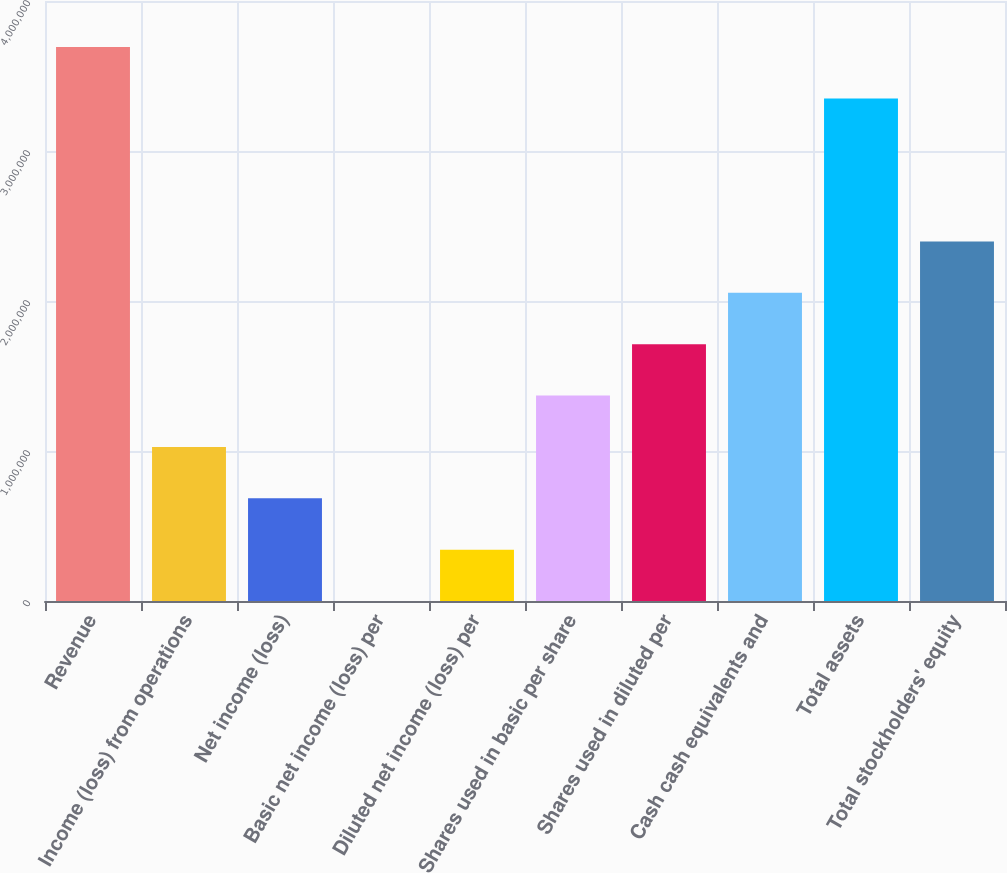<chart> <loc_0><loc_0><loc_500><loc_500><bar_chart><fcel>Revenue<fcel>Income (loss) from operations<fcel>Net income (loss)<fcel>Basic net income (loss) per<fcel>Diluted net income (loss) per<fcel>Shares used in basic per share<fcel>Shares used in diluted per<fcel>Cash cash equivalents and<fcel>Total assets<fcel>Total stockholders' equity<nl><fcel>3.69321e+06<fcel>1.02746e+06<fcel>684972<fcel>0.05<fcel>342486<fcel>1.36994e+06<fcel>1.71243e+06<fcel>2.05492e+06<fcel>3.35073e+06<fcel>2.3974e+06<nl></chart> 